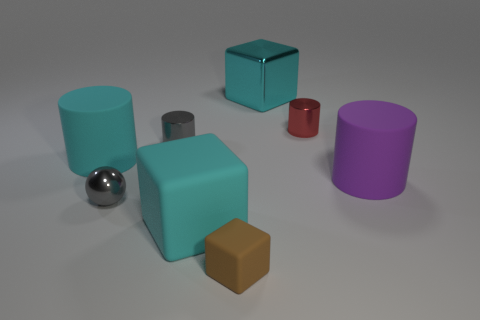Subtract all purple blocks. Subtract all yellow spheres. How many blocks are left? 3 Add 2 small cyan rubber balls. How many objects exist? 10 Subtract all cubes. How many objects are left? 5 Add 1 red metal cylinders. How many red metal cylinders are left? 2 Add 5 tiny gray spheres. How many tiny gray spheres exist? 6 Subtract 0 cyan balls. How many objects are left? 8 Subtract all small yellow metal cubes. Subtract all cyan matte objects. How many objects are left? 6 